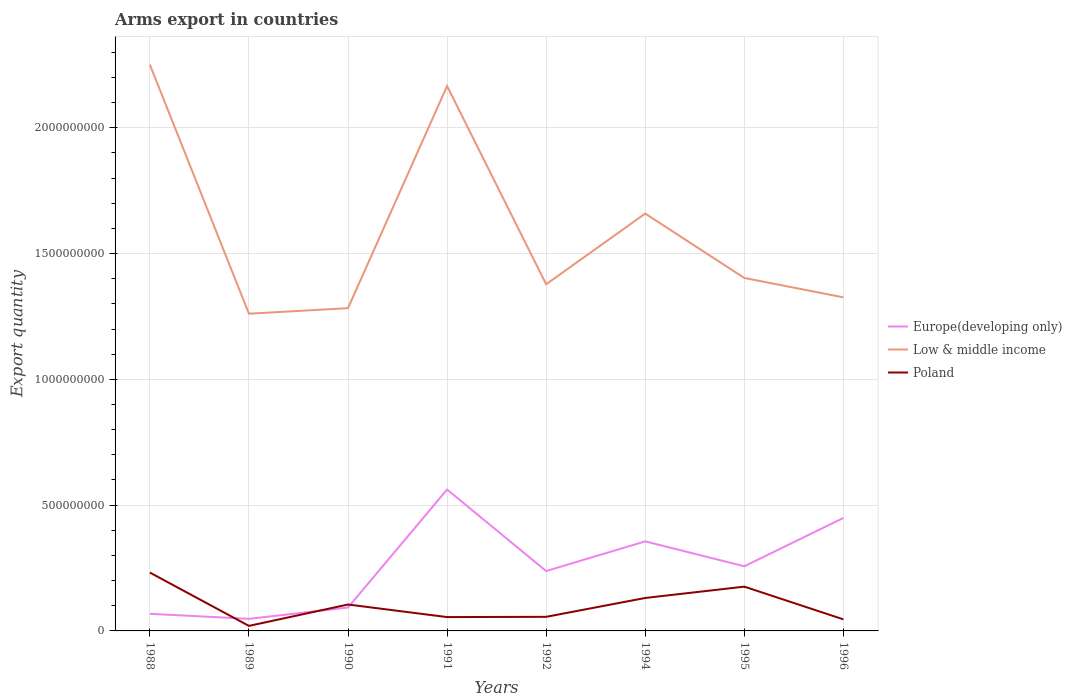How many different coloured lines are there?
Offer a very short reply. 3. Does the line corresponding to Europe(developing only) intersect with the line corresponding to Low & middle income?
Your answer should be compact. No. Is the number of lines equal to the number of legend labels?
Provide a short and direct response. Yes. Across all years, what is the maximum total arms export in Europe(developing only)?
Give a very brief answer. 4.80e+07. What is the total total arms export in Poland in the graph?
Your response must be concise. -8.50e+07. What is the difference between the highest and the second highest total arms export in Europe(developing only)?
Your response must be concise. 5.14e+08. Is the total arms export in Poland strictly greater than the total arms export in Low & middle income over the years?
Ensure brevity in your answer.  Yes. How many years are there in the graph?
Give a very brief answer. 8. Does the graph contain any zero values?
Make the answer very short. No. Where does the legend appear in the graph?
Your response must be concise. Center right. How are the legend labels stacked?
Offer a terse response. Vertical. What is the title of the graph?
Offer a very short reply. Arms export in countries. Does "Armenia" appear as one of the legend labels in the graph?
Offer a terse response. No. What is the label or title of the Y-axis?
Your answer should be very brief. Export quantity. What is the Export quantity of Europe(developing only) in 1988?
Provide a succinct answer. 6.80e+07. What is the Export quantity in Low & middle income in 1988?
Your answer should be very brief. 2.25e+09. What is the Export quantity in Poland in 1988?
Offer a very short reply. 2.32e+08. What is the Export quantity of Europe(developing only) in 1989?
Offer a terse response. 4.80e+07. What is the Export quantity of Low & middle income in 1989?
Your answer should be very brief. 1.26e+09. What is the Export quantity in Europe(developing only) in 1990?
Make the answer very short. 9.30e+07. What is the Export quantity of Low & middle income in 1990?
Offer a very short reply. 1.28e+09. What is the Export quantity of Poland in 1990?
Provide a succinct answer. 1.05e+08. What is the Export quantity in Europe(developing only) in 1991?
Offer a terse response. 5.62e+08. What is the Export quantity of Low & middle income in 1991?
Your answer should be compact. 2.17e+09. What is the Export quantity in Poland in 1991?
Ensure brevity in your answer.  5.50e+07. What is the Export quantity of Europe(developing only) in 1992?
Offer a very short reply. 2.38e+08. What is the Export quantity of Low & middle income in 1992?
Your response must be concise. 1.38e+09. What is the Export quantity in Poland in 1992?
Ensure brevity in your answer.  5.60e+07. What is the Export quantity of Europe(developing only) in 1994?
Your response must be concise. 3.56e+08. What is the Export quantity of Low & middle income in 1994?
Offer a very short reply. 1.66e+09. What is the Export quantity of Poland in 1994?
Give a very brief answer. 1.31e+08. What is the Export quantity in Europe(developing only) in 1995?
Provide a succinct answer. 2.57e+08. What is the Export quantity of Low & middle income in 1995?
Provide a short and direct response. 1.40e+09. What is the Export quantity of Poland in 1995?
Provide a short and direct response. 1.76e+08. What is the Export quantity of Europe(developing only) in 1996?
Offer a terse response. 4.49e+08. What is the Export quantity in Low & middle income in 1996?
Give a very brief answer. 1.33e+09. What is the Export quantity of Poland in 1996?
Give a very brief answer. 4.60e+07. Across all years, what is the maximum Export quantity in Europe(developing only)?
Offer a terse response. 5.62e+08. Across all years, what is the maximum Export quantity of Low & middle income?
Your response must be concise. 2.25e+09. Across all years, what is the maximum Export quantity of Poland?
Provide a short and direct response. 2.32e+08. Across all years, what is the minimum Export quantity in Europe(developing only)?
Ensure brevity in your answer.  4.80e+07. Across all years, what is the minimum Export quantity of Low & middle income?
Provide a succinct answer. 1.26e+09. Across all years, what is the minimum Export quantity of Poland?
Make the answer very short. 2.00e+07. What is the total Export quantity in Europe(developing only) in the graph?
Keep it short and to the point. 2.07e+09. What is the total Export quantity of Low & middle income in the graph?
Keep it short and to the point. 1.27e+1. What is the total Export quantity of Poland in the graph?
Your response must be concise. 8.21e+08. What is the difference between the Export quantity in Low & middle income in 1988 and that in 1989?
Offer a terse response. 9.90e+08. What is the difference between the Export quantity in Poland in 1988 and that in 1989?
Make the answer very short. 2.12e+08. What is the difference between the Export quantity of Europe(developing only) in 1988 and that in 1990?
Ensure brevity in your answer.  -2.50e+07. What is the difference between the Export quantity of Low & middle income in 1988 and that in 1990?
Keep it short and to the point. 9.68e+08. What is the difference between the Export quantity in Poland in 1988 and that in 1990?
Ensure brevity in your answer.  1.27e+08. What is the difference between the Export quantity in Europe(developing only) in 1988 and that in 1991?
Offer a terse response. -4.94e+08. What is the difference between the Export quantity in Low & middle income in 1988 and that in 1991?
Give a very brief answer. 8.50e+07. What is the difference between the Export quantity in Poland in 1988 and that in 1991?
Provide a short and direct response. 1.77e+08. What is the difference between the Export quantity of Europe(developing only) in 1988 and that in 1992?
Keep it short and to the point. -1.70e+08. What is the difference between the Export quantity of Low & middle income in 1988 and that in 1992?
Your response must be concise. 8.73e+08. What is the difference between the Export quantity of Poland in 1988 and that in 1992?
Keep it short and to the point. 1.76e+08. What is the difference between the Export quantity of Europe(developing only) in 1988 and that in 1994?
Your answer should be compact. -2.88e+08. What is the difference between the Export quantity of Low & middle income in 1988 and that in 1994?
Give a very brief answer. 5.92e+08. What is the difference between the Export quantity of Poland in 1988 and that in 1994?
Your response must be concise. 1.01e+08. What is the difference between the Export quantity in Europe(developing only) in 1988 and that in 1995?
Offer a very short reply. -1.89e+08. What is the difference between the Export quantity of Low & middle income in 1988 and that in 1995?
Offer a terse response. 8.48e+08. What is the difference between the Export quantity of Poland in 1988 and that in 1995?
Offer a terse response. 5.60e+07. What is the difference between the Export quantity of Europe(developing only) in 1988 and that in 1996?
Your answer should be very brief. -3.81e+08. What is the difference between the Export quantity of Low & middle income in 1988 and that in 1996?
Provide a short and direct response. 9.25e+08. What is the difference between the Export quantity in Poland in 1988 and that in 1996?
Provide a short and direct response. 1.86e+08. What is the difference between the Export quantity in Europe(developing only) in 1989 and that in 1990?
Provide a short and direct response. -4.50e+07. What is the difference between the Export quantity in Low & middle income in 1989 and that in 1990?
Offer a terse response. -2.20e+07. What is the difference between the Export quantity of Poland in 1989 and that in 1990?
Make the answer very short. -8.50e+07. What is the difference between the Export quantity of Europe(developing only) in 1989 and that in 1991?
Make the answer very short. -5.14e+08. What is the difference between the Export quantity of Low & middle income in 1989 and that in 1991?
Your answer should be compact. -9.05e+08. What is the difference between the Export quantity of Poland in 1989 and that in 1991?
Keep it short and to the point. -3.50e+07. What is the difference between the Export quantity of Europe(developing only) in 1989 and that in 1992?
Give a very brief answer. -1.90e+08. What is the difference between the Export quantity in Low & middle income in 1989 and that in 1992?
Keep it short and to the point. -1.17e+08. What is the difference between the Export quantity of Poland in 1989 and that in 1992?
Your answer should be compact. -3.60e+07. What is the difference between the Export quantity of Europe(developing only) in 1989 and that in 1994?
Offer a very short reply. -3.08e+08. What is the difference between the Export quantity in Low & middle income in 1989 and that in 1994?
Give a very brief answer. -3.98e+08. What is the difference between the Export quantity of Poland in 1989 and that in 1994?
Keep it short and to the point. -1.11e+08. What is the difference between the Export quantity in Europe(developing only) in 1989 and that in 1995?
Your response must be concise. -2.09e+08. What is the difference between the Export quantity of Low & middle income in 1989 and that in 1995?
Your answer should be very brief. -1.42e+08. What is the difference between the Export quantity of Poland in 1989 and that in 1995?
Your response must be concise. -1.56e+08. What is the difference between the Export quantity of Europe(developing only) in 1989 and that in 1996?
Provide a short and direct response. -4.01e+08. What is the difference between the Export quantity in Low & middle income in 1989 and that in 1996?
Your response must be concise. -6.50e+07. What is the difference between the Export quantity in Poland in 1989 and that in 1996?
Give a very brief answer. -2.60e+07. What is the difference between the Export quantity in Europe(developing only) in 1990 and that in 1991?
Give a very brief answer. -4.69e+08. What is the difference between the Export quantity in Low & middle income in 1990 and that in 1991?
Provide a succinct answer. -8.83e+08. What is the difference between the Export quantity in Europe(developing only) in 1990 and that in 1992?
Make the answer very short. -1.45e+08. What is the difference between the Export quantity of Low & middle income in 1990 and that in 1992?
Make the answer very short. -9.50e+07. What is the difference between the Export quantity in Poland in 1990 and that in 1992?
Give a very brief answer. 4.90e+07. What is the difference between the Export quantity of Europe(developing only) in 1990 and that in 1994?
Keep it short and to the point. -2.63e+08. What is the difference between the Export quantity of Low & middle income in 1990 and that in 1994?
Offer a terse response. -3.76e+08. What is the difference between the Export quantity in Poland in 1990 and that in 1994?
Ensure brevity in your answer.  -2.60e+07. What is the difference between the Export quantity of Europe(developing only) in 1990 and that in 1995?
Offer a very short reply. -1.64e+08. What is the difference between the Export quantity in Low & middle income in 1990 and that in 1995?
Your answer should be compact. -1.20e+08. What is the difference between the Export quantity in Poland in 1990 and that in 1995?
Offer a terse response. -7.10e+07. What is the difference between the Export quantity in Europe(developing only) in 1990 and that in 1996?
Provide a short and direct response. -3.56e+08. What is the difference between the Export quantity in Low & middle income in 1990 and that in 1996?
Make the answer very short. -4.30e+07. What is the difference between the Export quantity in Poland in 1990 and that in 1996?
Give a very brief answer. 5.90e+07. What is the difference between the Export quantity in Europe(developing only) in 1991 and that in 1992?
Provide a succinct answer. 3.24e+08. What is the difference between the Export quantity in Low & middle income in 1991 and that in 1992?
Your answer should be very brief. 7.88e+08. What is the difference between the Export quantity in Poland in 1991 and that in 1992?
Your response must be concise. -1.00e+06. What is the difference between the Export quantity of Europe(developing only) in 1991 and that in 1994?
Your response must be concise. 2.06e+08. What is the difference between the Export quantity in Low & middle income in 1991 and that in 1994?
Provide a succinct answer. 5.07e+08. What is the difference between the Export quantity in Poland in 1991 and that in 1994?
Make the answer very short. -7.60e+07. What is the difference between the Export quantity of Europe(developing only) in 1991 and that in 1995?
Keep it short and to the point. 3.05e+08. What is the difference between the Export quantity in Low & middle income in 1991 and that in 1995?
Provide a short and direct response. 7.63e+08. What is the difference between the Export quantity in Poland in 1991 and that in 1995?
Your answer should be compact. -1.21e+08. What is the difference between the Export quantity of Europe(developing only) in 1991 and that in 1996?
Your answer should be compact. 1.13e+08. What is the difference between the Export quantity in Low & middle income in 1991 and that in 1996?
Offer a very short reply. 8.40e+08. What is the difference between the Export quantity in Poland in 1991 and that in 1996?
Your response must be concise. 9.00e+06. What is the difference between the Export quantity in Europe(developing only) in 1992 and that in 1994?
Your answer should be compact. -1.18e+08. What is the difference between the Export quantity in Low & middle income in 1992 and that in 1994?
Your response must be concise. -2.81e+08. What is the difference between the Export quantity in Poland in 1992 and that in 1994?
Provide a succinct answer. -7.50e+07. What is the difference between the Export quantity in Europe(developing only) in 1992 and that in 1995?
Provide a short and direct response. -1.90e+07. What is the difference between the Export quantity of Low & middle income in 1992 and that in 1995?
Your answer should be compact. -2.50e+07. What is the difference between the Export quantity in Poland in 1992 and that in 1995?
Give a very brief answer. -1.20e+08. What is the difference between the Export quantity of Europe(developing only) in 1992 and that in 1996?
Keep it short and to the point. -2.11e+08. What is the difference between the Export quantity in Low & middle income in 1992 and that in 1996?
Your answer should be compact. 5.20e+07. What is the difference between the Export quantity in Poland in 1992 and that in 1996?
Ensure brevity in your answer.  1.00e+07. What is the difference between the Export quantity of Europe(developing only) in 1994 and that in 1995?
Your response must be concise. 9.90e+07. What is the difference between the Export quantity in Low & middle income in 1994 and that in 1995?
Offer a very short reply. 2.56e+08. What is the difference between the Export quantity of Poland in 1994 and that in 1995?
Your answer should be compact. -4.50e+07. What is the difference between the Export quantity in Europe(developing only) in 1994 and that in 1996?
Your response must be concise. -9.30e+07. What is the difference between the Export quantity of Low & middle income in 1994 and that in 1996?
Provide a succinct answer. 3.33e+08. What is the difference between the Export quantity of Poland in 1994 and that in 1996?
Your answer should be very brief. 8.50e+07. What is the difference between the Export quantity of Europe(developing only) in 1995 and that in 1996?
Provide a short and direct response. -1.92e+08. What is the difference between the Export quantity in Low & middle income in 1995 and that in 1996?
Make the answer very short. 7.70e+07. What is the difference between the Export quantity in Poland in 1995 and that in 1996?
Ensure brevity in your answer.  1.30e+08. What is the difference between the Export quantity of Europe(developing only) in 1988 and the Export quantity of Low & middle income in 1989?
Give a very brief answer. -1.19e+09. What is the difference between the Export quantity of Europe(developing only) in 1988 and the Export quantity of Poland in 1989?
Give a very brief answer. 4.80e+07. What is the difference between the Export quantity of Low & middle income in 1988 and the Export quantity of Poland in 1989?
Provide a succinct answer. 2.23e+09. What is the difference between the Export quantity in Europe(developing only) in 1988 and the Export quantity in Low & middle income in 1990?
Offer a very short reply. -1.22e+09. What is the difference between the Export quantity in Europe(developing only) in 1988 and the Export quantity in Poland in 1990?
Your answer should be very brief. -3.70e+07. What is the difference between the Export quantity in Low & middle income in 1988 and the Export quantity in Poland in 1990?
Offer a very short reply. 2.15e+09. What is the difference between the Export quantity of Europe(developing only) in 1988 and the Export quantity of Low & middle income in 1991?
Keep it short and to the point. -2.10e+09. What is the difference between the Export quantity in Europe(developing only) in 1988 and the Export quantity in Poland in 1991?
Your answer should be compact. 1.30e+07. What is the difference between the Export quantity of Low & middle income in 1988 and the Export quantity of Poland in 1991?
Ensure brevity in your answer.  2.20e+09. What is the difference between the Export quantity of Europe(developing only) in 1988 and the Export quantity of Low & middle income in 1992?
Provide a succinct answer. -1.31e+09. What is the difference between the Export quantity of Low & middle income in 1988 and the Export quantity of Poland in 1992?
Your answer should be very brief. 2.20e+09. What is the difference between the Export quantity in Europe(developing only) in 1988 and the Export quantity in Low & middle income in 1994?
Your answer should be compact. -1.59e+09. What is the difference between the Export quantity in Europe(developing only) in 1988 and the Export quantity in Poland in 1994?
Your answer should be very brief. -6.30e+07. What is the difference between the Export quantity of Low & middle income in 1988 and the Export quantity of Poland in 1994?
Ensure brevity in your answer.  2.12e+09. What is the difference between the Export quantity of Europe(developing only) in 1988 and the Export quantity of Low & middle income in 1995?
Keep it short and to the point. -1.34e+09. What is the difference between the Export quantity of Europe(developing only) in 1988 and the Export quantity of Poland in 1995?
Ensure brevity in your answer.  -1.08e+08. What is the difference between the Export quantity of Low & middle income in 1988 and the Export quantity of Poland in 1995?
Offer a terse response. 2.08e+09. What is the difference between the Export quantity of Europe(developing only) in 1988 and the Export quantity of Low & middle income in 1996?
Your response must be concise. -1.26e+09. What is the difference between the Export quantity of Europe(developing only) in 1988 and the Export quantity of Poland in 1996?
Provide a succinct answer. 2.20e+07. What is the difference between the Export quantity in Low & middle income in 1988 and the Export quantity in Poland in 1996?
Offer a terse response. 2.20e+09. What is the difference between the Export quantity of Europe(developing only) in 1989 and the Export quantity of Low & middle income in 1990?
Your response must be concise. -1.24e+09. What is the difference between the Export quantity of Europe(developing only) in 1989 and the Export quantity of Poland in 1990?
Keep it short and to the point. -5.70e+07. What is the difference between the Export quantity in Low & middle income in 1989 and the Export quantity in Poland in 1990?
Your answer should be compact. 1.16e+09. What is the difference between the Export quantity of Europe(developing only) in 1989 and the Export quantity of Low & middle income in 1991?
Make the answer very short. -2.12e+09. What is the difference between the Export quantity in Europe(developing only) in 1989 and the Export quantity in Poland in 1991?
Your answer should be very brief. -7.00e+06. What is the difference between the Export quantity in Low & middle income in 1989 and the Export quantity in Poland in 1991?
Your response must be concise. 1.21e+09. What is the difference between the Export quantity in Europe(developing only) in 1989 and the Export quantity in Low & middle income in 1992?
Offer a terse response. -1.33e+09. What is the difference between the Export quantity of Europe(developing only) in 1989 and the Export quantity of Poland in 1992?
Offer a very short reply. -8.00e+06. What is the difference between the Export quantity of Low & middle income in 1989 and the Export quantity of Poland in 1992?
Offer a very short reply. 1.20e+09. What is the difference between the Export quantity in Europe(developing only) in 1989 and the Export quantity in Low & middle income in 1994?
Make the answer very short. -1.61e+09. What is the difference between the Export quantity of Europe(developing only) in 1989 and the Export quantity of Poland in 1994?
Offer a terse response. -8.30e+07. What is the difference between the Export quantity of Low & middle income in 1989 and the Export quantity of Poland in 1994?
Make the answer very short. 1.13e+09. What is the difference between the Export quantity of Europe(developing only) in 1989 and the Export quantity of Low & middle income in 1995?
Give a very brief answer. -1.36e+09. What is the difference between the Export quantity in Europe(developing only) in 1989 and the Export quantity in Poland in 1995?
Ensure brevity in your answer.  -1.28e+08. What is the difference between the Export quantity in Low & middle income in 1989 and the Export quantity in Poland in 1995?
Provide a succinct answer. 1.08e+09. What is the difference between the Export quantity in Europe(developing only) in 1989 and the Export quantity in Low & middle income in 1996?
Keep it short and to the point. -1.28e+09. What is the difference between the Export quantity in Europe(developing only) in 1989 and the Export quantity in Poland in 1996?
Your response must be concise. 2.00e+06. What is the difference between the Export quantity of Low & middle income in 1989 and the Export quantity of Poland in 1996?
Offer a very short reply. 1.22e+09. What is the difference between the Export quantity of Europe(developing only) in 1990 and the Export quantity of Low & middle income in 1991?
Give a very brief answer. -2.07e+09. What is the difference between the Export quantity in Europe(developing only) in 1990 and the Export quantity in Poland in 1991?
Give a very brief answer. 3.80e+07. What is the difference between the Export quantity of Low & middle income in 1990 and the Export quantity of Poland in 1991?
Provide a succinct answer. 1.23e+09. What is the difference between the Export quantity of Europe(developing only) in 1990 and the Export quantity of Low & middle income in 1992?
Make the answer very short. -1.28e+09. What is the difference between the Export quantity in Europe(developing only) in 1990 and the Export quantity in Poland in 1992?
Keep it short and to the point. 3.70e+07. What is the difference between the Export quantity in Low & middle income in 1990 and the Export quantity in Poland in 1992?
Provide a short and direct response. 1.23e+09. What is the difference between the Export quantity in Europe(developing only) in 1990 and the Export quantity in Low & middle income in 1994?
Offer a very short reply. -1.57e+09. What is the difference between the Export quantity of Europe(developing only) in 1990 and the Export quantity of Poland in 1994?
Your response must be concise. -3.80e+07. What is the difference between the Export quantity of Low & middle income in 1990 and the Export quantity of Poland in 1994?
Give a very brief answer. 1.15e+09. What is the difference between the Export quantity of Europe(developing only) in 1990 and the Export quantity of Low & middle income in 1995?
Provide a short and direct response. -1.31e+09. What is the difference between the Export quantity in Europe(developing only) in 1990 and the Export quantity in Poland in 1995?
Ensure brevity in your answer.  -8.30e+07. What is the difference between the Export quantity in Low & middle income in 1990 and the Export quantity in Poland in 1995?
Give a very brief answer. 1.11e+09. What is the difference between the Export quantity of Europe(developing only) in 1990 and the Export quantity of Low & middle income in 1996?
Your answer should be compact. -1.23e+09. What is the difference between the Export quantity in Europe(developing only) in 1990 and the Export quantity in Poland in 1996?
Your answer should be very brief. 4.70e+07. What is the difference between the Export quantity in Low & middle income in 1990 and the Export quantity in Poland in 1996?
Your response must be concise. 1.24e+09. What is the difference between the Export quantity in Europe(developing only) in 1991 and the Export quantity in Low & middle income in 1992?
Keep it short and to the point. -8.16e+08. What is the difference between the Export quantity of Europe(developing only) in 1991 and the Export quantity of Poland in 1992?
Your response must be concise. 5.06e+08. What is the difference between the Export quantity of Low & middle income in 1991 and the Export quantity of Poland in 1992?
Provide a short and direct response. 2.11e+09. What is the difference between the Export quantity in Europe(developing only) in 1991 and the Export quantity in Low & middle income in 1994?
Provide a short and direct response. -1.10e+09. What is the difference between the Export quantity in Europe(developing only) in 1991 and the Export quantity in Poland in 1994?
Ensure brevity in your answer.  4.31e+08. What is the difference between the Export quantity in Low & middle income in 1991 and the Export quantity in Poland in 1994?
Your answer should be very brief. 2.04e+09. What is the difference between the Export quantity of Europe(developing only) in 1991 and the Export quantity of Low & middle income in 1995?
Offer a terse response. -8.41e+08. What is the difference between the Export quantity in Europe(developing only) in 1991 and the Export quantity in Poland in 1995?
Ensure brevity in your answer.  3.86e+08. What is the difference between the Export quantity of Low & middle income in 1991 and the Export quantity of Poland in 1995?
Your answer should be compact. 1.99e+09. What is the difference between the Export quantity in Europe(developing only) in 1991 and the Export quantity in Low & middle income in 1996?
Your answer should be compact. -7.64e+08. What is the difference between the Export quantity of Europe(developing only) in 1991 and the Export quantity of Poland in 1996?
Make the answer very short. 5.16e+08. What is the difference between the Export quantity in Low & middle income in 1991 and the Export quantity in Poland in 1996?
Your answer should be compact. 2.12e+09. What is the difference between the Export quantity in Europe(developing only) in 1992 and the Export quantity in Low & middle income in 1994?
Give a very brief answer. -1.42e+09. What is the difference between the Export quantity in Europe(developing only) in 1992 and the Export quantity in Poland in 1994?
Provide a short and direct response. 1.07e+08. What is the difference between the Export quantity in Low & middle income in 1992 and the Export quantity in Poland in 1994?
Give a very brief answer. 1.25e+09. What is the difference between the Export quantity of Europe(developing only) in 1992 and the Export quantity of Low & middle income in 1995?
Offer a very short reply. -1.16e+09. What is the difference between the Export quantity of Europe(developing only) in 1992 and the Export quantity of Poland in 1995?
Keep it short and to the point. 6.20e+07. What is the difference between the Export quantity in Low & middle income in 1992 and the Export quantity in Poland in 1995?
Offer a very short reply. 1.20e+09. What is the difference between the Export quantity of Europe(developing only) in 1992 and the Export quantity of Low & middle income in 1996?
Ensure brevity in your answer.  -1.09e+09. What is the difference between the Export quantity in Europe(developing only) in 1992 and the Export quantity in Poland in 1996?
Your answer should be compact. 1.92e+08. What is the difference between the Export quantity of Low & middle income in 1992 and the Export quantity of Poland in 1996?
Your answer should be very brief. 1.33e+09. What is the difference between the Export quantity of Europe(developing only) in 1994 and the Export quantity of Low & middle income in 1995?
Your answer should be compact. -1.05e+09. What is the difference between the Export quantity in Europe(developing only) in 1994 and the Export quantity in Poland in 1995?
Keep it short and to the point. 1.80e+08. What is the difference between the Export quantity in Low & middle income in 1994 and the Export quantity in Poland in 1995?
Give a very brief answer. 1.48e+09. What is the difference between the Export quantity of Europe(developing only) in 1994 and the Export quantity of Low & middle income in 1996?
Your response must be concise. -9.70e+08. What is the difference between the Export quantity in Europe(developing only) in 1994 and the Export quantity in Poland in 1996?
Ensure brevity in your answer.  3.10e+08. What is the difference between the Export quantity of Low & middle income in 1994 and the Export quantity of Poland in 1996?
Give a very brief answer. 1.61e+09. What is the difference between the Export quantity of Europe(developing only) in 1995 and the Export quantity of Low & middle income in 1996?
Your answer should be very brief. -1.07e+09. What is the difference between the Export quantity in Europe(developing only) in 1995 and the Export quantity in Poland in 1996?
Provide a succinct answer. 2.11e+08. What is the difference between the Export quantity in Low & middle income in 1995 and the Export quantity in Poland in 1996?
Provide a short and direct response. 1.36e+09. What is the average Export quantity in Europe(developing only) per year?
Offer a very short reply. 2.59e+08. What is the average Export quantity of Low & middle income per year?
Your answer should be compact. 1.59e+09. What is the average Export quantity in Poland per year?
Offer a very short reply. 1.03e+08. In the year 1988, what is the difference between the Export quantity in Europe(developing only) and Export quantity in Low & middle income?
Offer a very short reply. -2.18e+09. In the year 1988, what is the difference between the Export quantity in Europe(developing only) and Export quantity in Poland?
Ensure brevity in your answer.  -1.64e+08. In the year 1988, what is the difference between the Export quantity in Low & middle income and Export quantity in Poland?
Provide a succinct answer. 2.02e+09. In the year 1989, what is the difference between the Export quantity in Europe(developing only) and Export quantity in Low & middle income?
Provide a succinct answer. -1.21e+09. In the year 1989, what is the difference between the Export quantity in Europe(developing only) and Export quantity in Poland?
Provide a succinct answer. 2.80e+07. In the year 1989, what is the difference between the Export quantity in Low & middle income and Export quantity in Poland?
Ensure brevity in your answer.  1.24e+09. In the year 1990, what is the difference between the Export quantity in Europe(developing only) and Export quantity in Low & middle income?
Ensure brevity in your answer.  -1.19e+09. In the year 1990, what is the difference between the Export quantity in Europe(developing only) and Export quantity in Poland?
Offer a very short reply. -1.20e+07. In the year 1990, what is the difference between the Export quantity of Low & middle income and Export quantity of Poland?
Your answer should be compact. 1.18e+09. In the year 1991, what is the difference between the Export quantity of Europe(developing only) and Export quantity of Low & middle income?
Your response must be concise. -1.60e+09. In the year 1991, what is the difference between the Export quantity in Europe(developing only) and Export quantity in Poland?
Provide a succinct answer. 5.07e+08. In the year 1991, what is the difference between the Export quantity of Low & middle income and Export quantity of Poland?
Your response must be concise. 2.11e+09. In the year 1992, what is the difference between the Export quantity of Europe(developing only) and Export quantity of Low & middle income?
Offer a terse response. -1.14e+09. In the year 1992, what is the difference between the Export quantity in Europe(developing only) and Export quantity in Poland?
Provide a succinct answer. 1.82e+08. In the year 1992, what is the difference between the Export quantity of Low & middle income and Export quantity of Poland?
Offer a terse response. 1.32e+09. In the year 1994, what is the difference between the Export quantity of Europe(developing only) and Export quantity of Low & middle income?
Offer a very short reply. -1.30e+09. In the year 1994, what is the difference between the Export quantity of Europe(developing only) and Export quantity of Poland?
Offer a terse response. 2.25e+08. In the year 1994, what is the difference between the Export quantity in Low & middle income and Export quantity in Poland?
Offer a very short reply. 1.53e+09. In the year 1995, what is the difference between the Export quantity in Europe(developing only) and Export quantity in Low & middle income?
Make the answer very short. -1.15e+09. In the year 1995, what is the difference between the Export quantity in Europe(developing only) and Export quantity in Poland?
Make the answer very short. 8.10e+07. In the year 1995, what is the difference between the Export quantity of Low & middle income and Export quantity of Poland?
Offer a terse response. 1.23e+09. In the year 1996, what is the difference between the Export quantity in Europe(developing only) and Export quantity in Low & middle income?
Your answer should be very brief. -8.77e+08. In the year 1996, what is the difference between the Export quantity of Europe(developing only) and Export quantity of Poland?
Provide a short and direct response. 4.03e+08. In the year 1996, what is the difference between the Export quantity of Low & middle income and Export quantity of Poland?
Provide a short and direct response. 1.28e+09. What is the ratio of the Export quantity in Europe(developing only) in 1988 to that in 1989?
Your answer should be compact. 1.42. What is the ratio of the Export quantity of Low & middle income in 1988 to that in 1989?
Give a very brief answer. 1.79. What is the ratio of the Export quantity in Europe(developing only) in 1988 to that in 1990?
Your answer should be compact. 0.73. What is the ratio of the Export quantity of Low & middle income in 1988 to that in 1990?
Ensure brevity in your answer.  1.75. What is the ratio of the Export quantity of Poland in 1988 to that in 1990?
Your answer should be compact. 2.21. What is the ratio of the Export quantity of Europe(developing only) in 1988 to that in 1991?
Offer a very short reply. 0.12. What is the ratio of the Export quantity of Low & middle income in 1988 to that in 1991?
Your answer should be compact. 1.04. What is the ratio of the Export quantity in Poland in 1988 to that in 1991?
Make the answer very short. 4.22. What is the ratio of the Export quantity in Europe(developing only) in 1988 to that in 1992?
Your answer should be compact. 0.29. What is the ratio of the Export quantity of Low & middle income in 1988 to that in 1992?
Your answer should be very brief. 1.63. What is the ratio of the Export quantity of Poland in 1988 to that in 1992?
Offer a terse response. 4.14. What is the ratio of the Export quantity in Europe(developing only) in 1988 to that in 1994?
Make the answer very short. 0.19. What is the ratio of the Export quantity of Low & middle income in 1988 to that in 1994?
Your answer should be compact. 1.36. What is the ratio of the Export quantity of Poland in 1988 to that in 1994?
Offer a very short reply. 1.77. What is the ratio of the Export quantity of Europe(developing only) in 1988 to that in 1995?
Provide a short and direct response. 0.26. What is the ratio of the Export quantity in Low & middle income in 1988 to that in 1995?
Keep it short and to the point. 1.6. What is the ratio of the Export quantity of Poland in 1988 to that in 1995?
Provide a short and direct response. 1.32. What is the ratio of the Export quantity in Europe(developing only) in 1988 to that in 1996?
Offer a very short reply. 0.15. What is the ratio of the Export quantity in Low & middle income in 1988 to that in 1996?
Your response must be concise. 1.7. What is the ratio of the Export quantity of Poland in 1988 to that in 1996?
Keep it short and to the point. 5.04. What is the ratio of the Export quantity of Europe(developing only) in 1989 to that in 1990?
Make the answer very short. 0.52. What is the ratio of the Export quantity in Low & middle income in 1989 to that in 1990?
Offer a terse response. 0.98. What is the ratio of the Export quantity in Poland in 1989 to that in 1990?
Give a very brief answer. 0.19. What is the ratio of the Export quantity in Europe(developing only) in 1989 to that in 1991?
Your answer should be very brief. 0.09. What is the ratio of the Export quantity in Low & middle income in 1989 to that in 1991?
Make the answer very short. 0.58. What is the ratio of the Export quantity of Poland in 1989 to that in 1991?
Your answer should be compact. 0.36. What is the ratio of the Export quantity in Europe(developing only) in 1989 to that in 1992?
Your answer should be very brief. 0.2. What is the ratio of the Export quantity of Low & middle income in 1989 to that in 1992?
Provide a short and direct response. 0.92. What is the ratio of the Export quantity of Poland in 1989 to that in 1992?
Ensure brevity in your answer.  0.36. What is the ratio of the Export quantity in Europe(developing only) in 1989 to that in 1994?
Your answer should be very brief. 0.13. What is the ratio of the Export quantity in Low & middle income in 1989 to that in 1994?
Provide a succinct answer. 0.76. What is the ratio of the Export quantity of Poland in 1989 to that in 1994?
Provide a short and direct response. 0.15. What is the ratio of the Export quantity of Europe(developing only) in 1989 to that in 1995?
Make the answer very short. 0.19. What is the ratio of the Export quantity in Low & middle income in 1989 to that in 1995?
Your answer should be compact. 0.9. What is the ratio of the Export quantity of Poland in 1989 to that in 1995?
Offer a very short reply. 0.11. What is the ratio of the Export quantity of Europe(developing only) in 1989 to that in 1996?
Your answer should be very brief. 0.11. What is the ratio of the Export quantity of Low & middle income in 1989 to that in 1996?
Your answer should be compact. 0.95. What is the ratio of the Export quantity of Poland in 1989 to that in 1996?
Provide a succinct answer. 0.43. What is the ratio of the Export quantity in Europe(developing only) in 1990 to that in 1991?
Give a very brief answer. 0.17. What is the ratio of the Export quantity of Low & middle income in 1990 to that in 1991?
Provide a succinct answer. 0.59. What is the ratio of the Export quantity of Poland in 1990 to that in 1991?
Offer a terse response. 1.91. What is the ratio of the Export quantity in Europe(developing only) in 1990 to that in 1992?
Offer a very short reply. 0.39. What is the ratio of the Export quantity in Low & middle income in 1990 to that in 1992?
Your answer should be very brief. 0.93. What is the ratio of the Export quantity of Poland in 1990 to that in 1992?
Ensure brevity in your answer.  1.88. What is the ratio of the Export quantity of Europe(developing only) in 1990 to that in 1994?
Keep it short and to the point. 0.26. What is the ratio of the Export quantity of Low & middle income in 1990 to that in 1994?
Keep it short and to the point. 0.77. What is the ratio of the Export quantity of Poland in 1990 to that in 1994?
Make the answer very short. 0.8. What is the ratio of the Export quantity of Europe(developing only) in 1990 to that in 1995?
Your answer should be compact. 0.36. What is the ratio of the Export quantity in Low & middle income in 1990 to that in 1995?
Your answer should be compact. 0.91. What is the ratio of the Export quantity of Poland in 1990 to that in 1995?
Provide a succinct answer. 0.6. What is the ratio of the Export quantity of Europe(developing only) in 1990 to that in 1996?
Your answer should be very brief. 0.21. What is the ratio of the Export quantity in Low & middle income in 1990 to that in 1996?
Your answer should be very brief. 0.97. What is the ratio of the Export quantity in Poland in 1990 to that in 1996?
Your response must be concise. 2.28. What is the ratio of the Export quantity in Europe(developing only) in 1991 to that in 1992?
Keep it short and to the point. 2.36. What is the ratio of the Export quantity of Low & middle income in 1991 to that in 1992?
Provide a short and direct response. 1.57. What is the ratio of the Export quantity in Poland in 1991 to that in 1992?
Make the answer very short. 0.98. What is the ratio of the Export quantity of Europe(developing only) in 1991 to that in 1994?
Ensure brevity in your answer.  1.58. What is the ratio of the Export quantity of Low & middle income in 1991 to that in 1994?
Provide a short and direct response. 1.31. What is the ratio of the Export quantity in Poland in 1991 to that in 1994?
Your answer should be very brief. 0.42. What is the ratio of the Export quantity of Europe(developing only) in 1991 to that in 1995?
Make the answer very short. 2.19. What is the ratio of the Export quantity of Low & middle income in 1991 to that in 1995?
Give a very brief answer. 1.54. What is the ratio of the Export quantity in Poland in 1991 to that in 1995?
Ensure brevity in your answer.  0.31. What is the ratio of the Export quantity in Europe(developing only) in 1991 to that in 1996?
Ensure brevity in your answer.  1.25. What is the ratio of the Export quantity of Low & middle income in 1991 to that in 1996?
Give a very brief answer. 1.63. What is the ratio of the Export quantity in Poland in 1991 to that in 1996?
Ensure brevity in your answer.  1.2. What is the ratio of the Export quantity in Europe(developing only) in 1992 to that in 1994?
Give a very brief answer. 0.67. What is the ratio of the Export quantity of Low & middle income in 1992 to that in 1994?
Offer a very short reply. 0.83. What is the ratio of the Export quantity in Poland in 1992 to that in 1994?
Your response must be concise. 0.43. What is the ratio of the Export quantity of Europe(developing only) in 1992 to that in 1995?
Offer a terse response. 0.93. What is the ratio of the Export quantity in Low & middle income in 1992 to that in 1995?
Offer a very short reply. 0.98. What is the ratio of the Export quantity in Poland in 1992 to that in 1995?
Ensure brevity in your answer.  0.32. What is the ratio of the Export quantity in Europe(developing only) in 1992 to that in 1996?
Your answer should be very brief. 0.53. What is the ratio of the Export quantity in Low & middle income in 1992 to that in 1996?
Give a very brief answer. 1.04. What is the ratio of the Export quantity of Poland in 1992 to that in 1996?
Provide a short and direct response. 1.22. What is the ratio of the Export quantity in Europe(developing only) in 1994 to that in 1995?
Provide a short and direct response. 1.39. What is the ratio of the Export quantity of Low & middle income in 1994 to that in 1995?
Your response must be concise. 1.18. What is the ratio of the Export quantity of Poland in 1994 to that in 1995?
Offer a terse response. 0.74. What is the ratio of the Export quantity of Europe(developing only) in 1994 to that in 1996?
Provide a short and direct response. 0.79. What is the ratio of the Export quantity in Low & middle income in 1994 to that in 1996?
Your response must be concise. 1.25. What is the ratio of the Export quantity in Poland in 1994 to that in 1996?
Your answer should be very brief. 2.85. What is the ratio of the Export quantity of Europe(developing only) in 1995 to that in 1996?
Provide a succinct answer. 0.57. What is the ratio of the Export quantity in Low & middle income in 1995 to that in 1996?
Provide a succinct answer. 1.06. What is the ratio of the Export quantity of Poland in 1995 to that in 1996?
Your answer should be compact. 3.83. What is the difference between the highest and the second highest Export quantity in Europe(developing only)?
Offer a terse response. 1.13e+08. What is the difference between the highest and the second highest Export quantity of Low & middle income?
Your answer should be compact. 8.50e+07. What is the difference between the highest and the second highest Export quantity of Poland?
Offer a very short reply. 5.60e+07. What is the difference between the highest and the lowest Export quantity of Europe(developing only)?
Keep it short and to the point. 5.14e+08. What is the difference between the highest and the lowest Export quantity in Low & middle income?
Provide a succinct answer. 9.90e+08. What is the difference between the highest and the lowest Export quantity in Poland?
Your answer should be compact. 2.12e+08. 